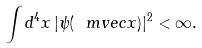Convert formula to latex. <formula><loc_0><loc_0><loc_500><loc_500>\int d ^ { 4 } x \, | \psi ( \ m v e c x ) | ^ { 2 } < \infty .</formula> 